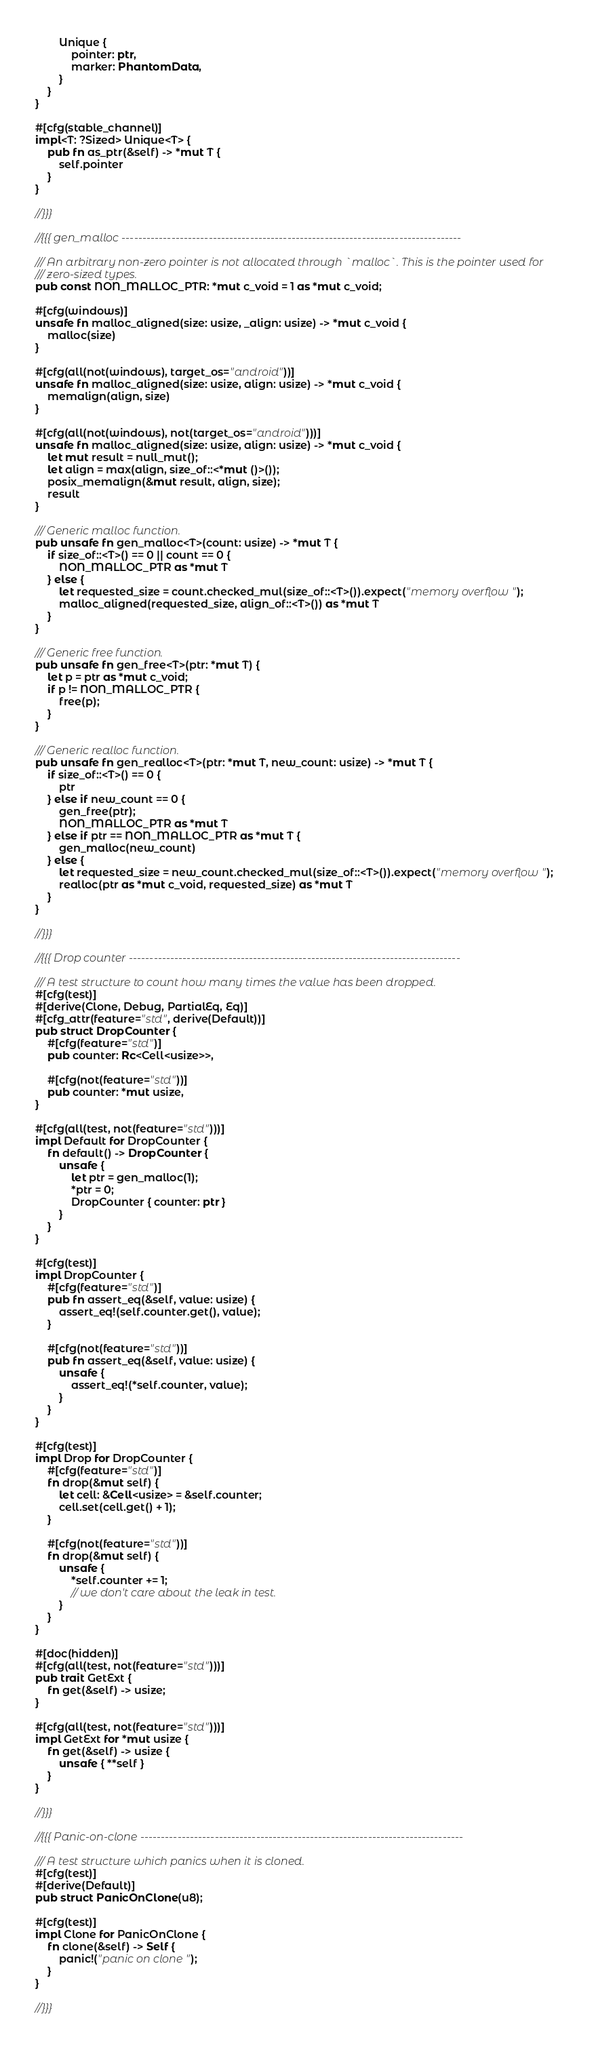<code> <loc_0><loc_0><loc_500><loc_500><_Rust_>        Unique {
            pointer: ptr,
            marker: PhantomData,
        }
    }
}

#[cfg(stable_channel)]
impl<T: ?Sized> Unique<T> {
    pub fn as_ptr(&self) -> *mut T {
        self.pointer
    }
}

//}}}

//{{{ gen_malloc ----------------------------------------------------------------------------------

/// An arbitrary non-zero pointer is not allocated through `malloc`. This is the pointer used for
/// zero-sized types.
pub const NON_MALLOC_PTR: *mut c_void = 1 as *mut c_void;

#[cfg(windows)]
unsafe fn malloc_aligned(size: usize, _align: usize) -> *mut c_void {
    malloc(size)
}

#[cfg(all(not(windows), target_os="android"))]
unsafe fn malloc_aligned(size: usize, align: usize) -> *mut c_void {
    memalign(align, size)
}

#[cfg(all(not(windows), not(target_os="android")))]
unsafe fn malloc_aligned(size: usize, align: usize) -> *mut c_void {
    let mut result = null_mut();
    let align = max(align, size_of::<*mut ()>());
    posix_memalign(&mut result, align, size);
    result
}

/// Generic malloc function.
pub unsafe fn gen_malloc<T>(count: usize) -> *mut T {
    if size_of::<T>() == 0 || count == 0 {
        NON_MALLOC_PTR as *mut T
    } else {
        let requested_size = count.checked_mul(size_of::<T>()).expect("memory overflow");
        malloc_aligned(requested_size, align_of::<T>()) as *mut T
    }
}

/// Generic free function.
pub unsafe fn gen_free<T>(ptr: *mut T) {
    let p = ptr as *mut c_void;
    if p != NON_MALLOC_PTR {
        free(p);
    }
}

/// Generic realloc function.
pub unsafe fn gen_realloc<T>(ptr: *mut T, new_count: usize) -> *mut T {
    if size_of::<T>() == 0 {
        ptr
    } else if new_count == 0 {
        gen_free(ptr);
        NON_MALLOC_PTR as *mut T
    } else if ptr == NON_MALLOC_PTR as *mut T {
        gen_malloc(new_count)
    } else {
        let requested_size = new_count.checked_mul(size_of::<T>()).expect("memory overflow");
        realloc(ptr as *mut c_void, requested_size) as *mut T
    }
}

//}}}

//{{{ Drop counter --------------------------------------------------------------------------------

/// A test structure to count how many times the value has been dropped.
#[cfg(test)]
#[derive(Clone, Debug, PartialEq, Eq)]
#[cfg_attr(feature="std", derive(Default))]
pub struct DropCounter {
    #[cfg(feature="std")]
    pub counter: Rc<Cell<usize>>,

    #[cfg(not(feature="std"))]
    pub counter: *mut usize,
}

#[cfg(all(test, not(feature="std")))]
impl Default for DropCounter {
    fn default() -> DropCounter {
        unsafe {
            let ptr = gen_malloc(1);
            *ptr = 0;
            DropCounter { counter: ptr }
        }
    }
}

#[cfg(test)]
impl DropCounter {
    #[cfg(feature="std")]
    pub fn assert_eq(&self, value: usize) {
        assert_eq!(self.counter.get(), value);
    }

    #[cfg(not(feature="std"))]
    pub fn assert_eq(&self, value: usize) {
        unsafe {
            assert_eq!(*self.counter, value);
        }
    }
}

#[cfg(test)]
impl Drop for DropCounter {
    #[cfg(feature="std")]
    fn drop(&mut self) {
        let cell: &Cell<usize> = &self.counter;
        cell.set(cell.get() + 1);
    }

    #[cfg(not(feature="std"))]
    fn drop(&mut self) {
        unsafe {
            *self.counter += 1;
            // we don't care about the leak in test.
        }
    }
}

#[doc(hidden)]
#[cfg(all(test, not(feature="std")))]
pub trait GetExt {
    fn get(&self) -> usize;
}

#[cfg(all(test, not(feature="std")))]
impl GetExt for *mut usize {
    fn get(&self) -> usize {
        unsafe { **self }
    }
}

//}}}

//{{{ Panic-on-clone ------------------------------------------------------------------------------

/// A test structure which panics when it is cloned.
#[cfg(test)]
#[derive(Default)]
pub struct PanicOnClone(u8);

#[cfg(test)]
impl Clone for PanicOnClone {
    fn clone(&self) -> Self {
        panic!("panic on clone");
    }
}

//}}}
</code> 